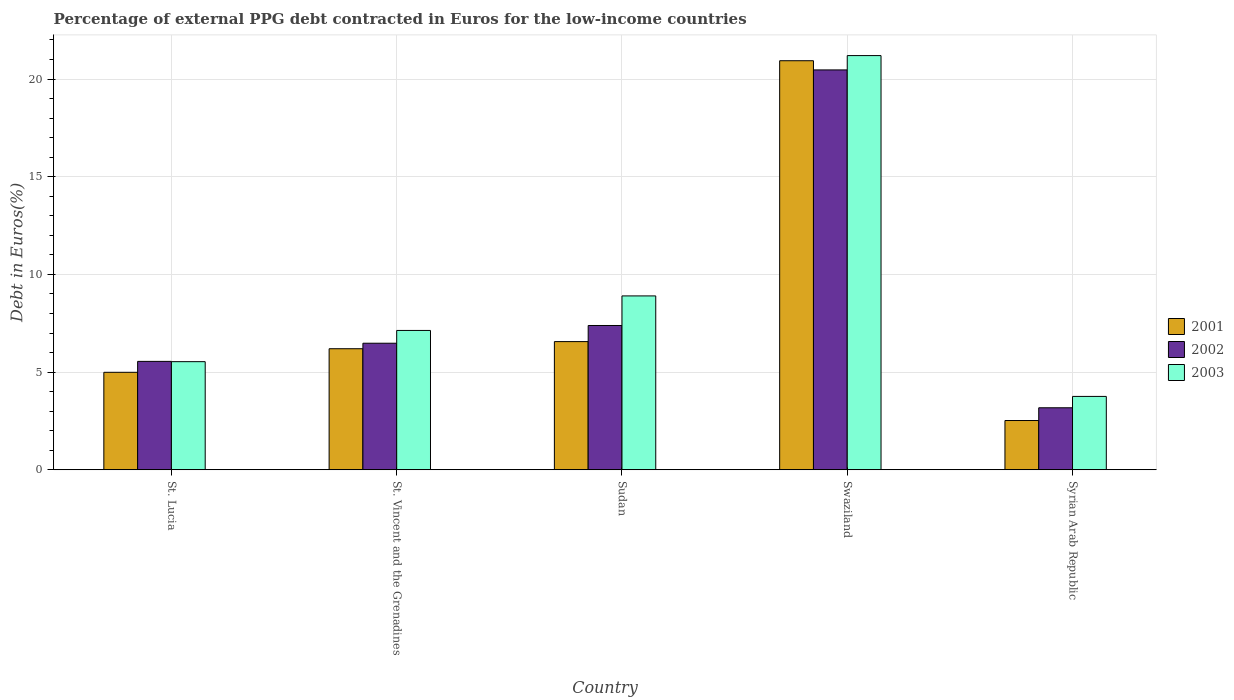How many bars are there on the 3rd tick from the left?
Ensure brevity in your answer.  3. What is the label of the 4th group of bars from the left?
Your answer should be very brief. Swaziland. In how many cases, is the number of bars for a given country not equal to the number of legend labels?
Offer a very short reply. 0. What is the percentage of external PPG debt contracted in Euros in 2002 in St. Vincent and the Grenadines?
Ensure brevity in your answer.  6.48. Across all countries, what is the maximum percentage of external PPG debt contracted in Euros in 2001?
Offer a very short reply. 20.94. Across all countries, what is the minimum percentage of external PPG debt contracted in Euros in 2003?
Give a very brief answer. 3.76. In which country was the percentage of external PPG debt contracted in Euros in 2003 maximum?
Your response must be concise. Swaziland. In which country was the percentage of external PPG debt contracted in Euros in 2002 minimum?
Give a very brief answer. Syrian Arab Republic. What is the total percentage of external PPG debt contracted in Euros in 2002 in the graph?
Your answer should be compact. 43.05. What is the difference between the percentage of external PPG debt contracted in Euros in 2002 in St. Lucia and that in Syrian Arab Republic?
Keep it short and to the point. 2.37. What is the difference between the percentage of external PPG debt contracted in Euros in 2001 in St. Lucia and the percentage of external PPG debt contracted in Euros in 2002 in Swaziland?
Provide a succinct answer. -15.48. What is the average percentage of external PPG debt contracted in Euros in 2001 per country?
Offer a very short reply. 8.24. What is the difference between the percentage of external PPG debt contracted in Euros of/in 2002 and percentage of external PPG debt contracted in Euros of/in 2001 in Swaziland?
Give a very brief answer. -0.47. What is the ratio of the percentage of external PPG debt contracted in Euros in 2001 in St. Vincent and the Grenadines to that in Syrian Arab Republic?
Keep it short and to the point. 2.46. Is the percentage of external PPG debt contracted in Euros in 2002 in St. Vincent and the Grenadines less than that in Syrian Arab Republic?
Keep it short and to the point. No. What is the difference between the highest and the second highest percentage of external PPG debt contracted in Euros in 2001?
Provide a succinct answer. 14.37. What is the difference between the highest and the lowest percentage of external PPG debt contracted in Euros in 2002?
Your answer should be very brief. 17.29. In how many countries, is the percentage of external PPG debt contracted in Euros in 2003 greater than the average percentage of external PPG debt contracted in Euros in 2003 taken over all countries?
Offer a terse response. 1. Does the graph contain any zero values?
Ensure brevity in your answer.  No. How are the legend labels stacked?
Your response must be concise. Vertical. What is the title of the graph?
Ensure brevity in your answer.  Percentage of external PPG debt contracted in Euros for the low-income countries. What is the label or title of the Y-axis?
Provide a succinct answer. Debt in Euros(%). What is the Debt in Euros(%) of 2001 in St. Lucia?
Provide a succinct answer. 4.99. What is the Debt in Euros(%) of 2002 in St. Lucia?
Offer a very short reply. 5.55. What is the Debt in Euros(%) of 2003 in St. Lucia?
Keep it short and to the point. 5.53. What is the Debt in Euros(%) of 2001 in St. Vincent and the Grenadines?
Ensure brevity in your answer.  6.2. What is the Debt in Euros(%) in 2002 in St. Vincent and the Grenadines?
Your answer should be compact. 6.48. What is the Debt in Euros(%) of 2003 in St. Vincent and the Grenadines?
Keep it short and to the point. 7.13. What is the Debt in Euros(%) of 2001 in Sudan?
Keep it short and to the point. 6.56. What is the Debt in Euros(%) in 2002 in Sudan?
Offer a terse response. 7.39. What is the Debt in Euros(%) of 2003 in Sudan?
Give a very brief answer. 8.9. What is the Debt in Euros(%) of 2001 in Swaziland?
Offer a terse response. 20.94. What is the Debt in Euros(%) in 2002 in Swaziland?
Ensure brevity in your answer.  20.47. What is the Debt in Euros(%) of 2003 in Swaziland?
Provide a succinct answer. 21.2. What is the Debt in Euros(%) of 2001 in Syrian Arab Republic?
Offer a terse response. 2.52. What is the Debt in Euros(%) in 2002 in Syrian Arab Republic?
Make the answer very short. 3.17. What is the Debt in Euros(%) of 2003 in Syrian Arab Republic?
Offer a terse response. 3.76. Across all countries, what is the maximum Debt in Euros(%) of 2001?
Provide a short and direct response. 20.94. Across all countries, what is the maximum Debt in Euros(%) in 2002?
Your answer should be very brief. 20.47. Across all countries, what is the maximum Debt in Euros(%) of 2003?
Provide a short and direct response. 21.2. Across all countries, what is the minimum Debt in Euros(%) of 2001?
Provide a succinct answer. 2.52. Across all countries, what is the minimum Debt in Euros(%) of 2002?
Keep it short and to the point. 3.17. Across all countries, what is the minimum Debt in Euros(%) of 2003?
Give a very brief answer. 3.76. What is the total Debt in Euros(%) in 2001 in the graph?
Offer a very short reply. 41.2. What is the total Debt in Euros(%) in 2002 in the graph?
Offer a terse response. 43.05. What is the total Debt in Euros(%) of 2003 in the graph?
Your answer should be very brief. 46.52. What is the difference between the Debt in Euros(%) of 2001 in St. Lucia and that in St. Vincent and the Grenadines?
Provide a succinct answer. -1.21. What is the difference between the Debt in Euros(%) of 2002 in St. Lucia and that in St. Vincent and the Grenadines?
Give a very brief answer. -0.93. What is the difference between the Debt in Euros(%) in 2003 in St. Lucia and that in St. Vincent and the Grenadines?
Provide a succinct answer. -1.6. What is the difference between the Debt in Euros(%) of 2001 in St. Lucia and that in Sudan?
Offer a very short reply. -1.57. What is the difference between the Debt in Euros(%) in 2002 in St. Lucia and that in Sudan?
Offer a very short reply. -1.84. What is the difference between the Debt in Euros(%) in 2003 in St. Lucia and that in Sudan?
Give a very brief answer. -3.37. What is the difference between the Debt in Euros(%) of 2001 in St. Lucia and that in Swaziland?
Make the answer very short. -15.95. What is the difference between the Debt in Euros(%) in 2002 in St. Lucia and that in Swaziland?
Your answer should be very brief. -14.92. What is the difference between the Debt in Euros(%) in 2003 in St. Lucia and that in Swaziland?
Provide a short and direct response. -15.66. What is the difference between the Debt in Euros(%) in 2001 in St. Lucia and that in Syrian Arab Republic?
Make the answer very short. 2.47. What is the difference between the Debt in Euros(%) in 2002 in St. Lucia and that in Syrian Arab Republic?
Your answer should be very brief. 2.37. What is the difference between the Debt in Euros(%) in 2003 in St. Lucia and that in Syrian Arab Republic?
Your response must be concise. 1.78. What is the difference between the Debt in Euros(%) of 2001 in St. Vincent and the Grenadines and that in Sudan?
Keep it short and to the point. -0.36. What is the difference between the Debt in Euros(%) in 2002 in St. Vincent and the Grenadines and that in Sudan?
Give a very brief answer. -0.91. What is the difference between the Debt in Euros(%) of 2003 in St. Vincent and the Grenadines and that in Sudan?
Your answer should be compact. -1.77. What is the difference between the Debt in Euros(%) of 2001 in St. Vincent and the Grenadines and that in Swaziland?
Your answer should be compact. -14.74. What is the difference between the Debt in Euros(%) of 2002 in St. Vincent and the Grenadines and that in Swaziland?
Your answer should be compact. -13.99. What is the difference between the Debt in Euros(%) in 2003 in St. Vincent and the Grenadines and that in Swaziland?
Your answer should be compact. -14.07. What is the difference between the Debt in Euros(%) in 2001 in St. Vincent and the Grenadines and that in Syrian Arab Republic?
Your answer should be very brief. 3.67. What is the difference between the Debt in Euros(%) of 2002 in St. Vincent and the Grenadines and that in Syrian Arab Republic?
Make the answer very short. 3.3. What is the difference between the Debt in Euros(%) of 2003 in St. Vincent and the Grenadines and that in Syrian Arab Republic?
Make the answer very short. 3.38. What is the difference between the Debt in Euros(%) of 2001 in Sudan and that in Swaziland?
Ensure brevity in your answer.  -14.37. What is the difference between the Debt in Euros(%) of 2002 in Sudan and that in Swaziland?
Your response must be concise. -13.08. What is the difference between the Debt in Euros(%) in 2003 in Sudan and that in Swaziland?
Your response must be concise. -12.3. What is the difference between the Debt in Euros(%) of 2001 in Sudan and that in Syrian Arab Republic?
Provide a short and direct response. 4.04. What is the difference between the Debt in Euros(%) in 2002 in Sudan and that in Syrian Arab Republic?
Your answer should be very brief. 4.21. What is the difference between the Debt in Euros(%) of 2003 in Sudan and that in Syrian Arab Republic?
Ensure brevity in your answer.  5.14. What is the difference between the Debt in Euros(%) of 2001 in Swaziland and that in Syrian Arab Republic?
Offer a terse response. 18.41. What is the difference between the Debt in Euros(%) in 2002 in Swaziland and that in Syrian Arab Republic?
Ensure brevity in your answer.  17.29. What is the difference between the Debt in Euros(%) of 2003 in Swaziland and that in Syrian Arab Republic?
Offer a very short reply. 17.44. What is the difference between the Debt in Euros(%) in 2001 in St. Lucia and the Debt in Euros(%) in 2002 in St. Vincent and the Grenadines?
Offer a terse response. -1.49. What is the difference between the Debt in Euros(%) of 2001 in St. Lucia and the Debt in Euros(%) of 2003 in St. Vincent and the Grenadines?
Make the answer very short. -2.14. What is the difference between the Debt in Euros(%) in 2002 in St. Lucia and the Debt in Euros(%) in 2003 in St. Vincent and the Grenadines?
Provide a short and direct response. -1.58. What is the difference between the Debt in Euros(%) in 2001 in St. Lucia and the Debt in Euros(%) in 2002 in Sudan?
Keep it short and to the point. -2.4. What is the difference between the Debt in Euros(%) of 2001 in St. Lucia and the Debt in Euros(%) of 2003 in Sudan?
Your answer should be very brief. -3.91. What is the difference between the Debt in Euros(%) in 2002 in St. Lucia and the Debt in Euros(%) in 2003 in Sudan?
Your response must be concise. -3.35. What is the difference between the Debt in Euros(%) in 2001 in St. Lucia and the Debt in Euros(%) in 2002 in Swaziland?
Offer a very short reply. -15.48. What is the difference between the Debt in Euros(%) in 2001 in St. Lucia and the Debt in Euros(%) in 2003 in Swaziland?
Keep it short and to the point. -16.21. What is the difference between the Debt in Euros(%) in 2002 in St. Lucia and the Debt in Euros(%) in 2003 in Swaziland?
Your response must be concise. -15.65. What is the difference between the Debt in Euros(%) of 2001 in St. Lucia and the Debt in Euros(%) of 2002 in Syrian Arab Republic?
Keep it short and to the point. 1.81. What is the difference between the Debt in Euros(%) of 2001 in St. Lucia and the Debt in Euros(%) of 2003 in Syrian Arab Republic?
Your answer should be very brief. 1.23. What is the difference between the Debt in Euros(%) in 2002 in St. Lucia and the Debt in Euros(%) in 2003 in Syrian Arab Republic?
Your answer should be very brief. 1.79. What is the difference between the Debt in Euros(%) in 2001 in St. Vincent and the Grenadines and the Debt in Euros(%) in 2002 in Sudan?
Keep it short and to the point. -1.19. What is the difference between the Debt in Euros(%) of 2001 in St. Vincent and the Grenadines and the Debt in Euros(%) of 2003 in Sudan?
Offer a very short reply. -2.7. What is the difference between the Debt in Euros(%) of 2002 in St. Vincent and the Grenadines and the Debt in Euros(%) of 2003 in Sudan?
Ensure brevity in your answer.  -2.42. What is the difference between the Debt in Euros(%) of 2001 in St. Vincent and the Grenadines and the Debt in Euros(%) of 2002 in Swaziland?
Keep it short and to the point. -14.27. What is the difference between the Debt in Euros(%) in 2001 in St. Vincent and the Grenadines and the Debt in Euros(%) in 2003 in Swaziland?
Make the answer very short. -15. What is the difference between the Debt in Euros(%) in 2002 in St. Vincent and the Grenadines and the Debt in Euros(%) in 2003 in Swaziland?
Give a very brief answer. -14.72. What is the difference between the Debt in Euros(%) in 2001 in St. Vincent and the Grenadines and the Debt in Euros(%) in 2002 in Syrian Arab Republic?
Your answer should be compact. 3.02. What is the difference between the Debt in Euros(%) of 2001 in St. Vincent and the Grenadines and the Debt in Euros(%) of 2003 in Syrian Arab Republic?
Your response must be concise. 2.44. What is the difference between the Debt in Euros(%) in 2002 in St. Vincent and the Grenadines and the Debt in Euros(%) in 2003 in Syrian Arab Republic?
Make the answer very short. 2.72. What is the difference between the Debt in Euros(%) in 2001 in Sudan and the Debt in Euros(%) in 2002 in Swaziland?
Offer a very short reply. -13.9. What is the difference between the Debt in Euros(%) of 2001 in Sudan and the Debt in Euros(%) of 2003 in Swaziland?
Make the answer very short. -14.64. What is the difference between the Debt in Euros(%) in 2002 in Sudan and the Debt in Euros(%) in 2003 in Swaziland?
Your response must be concise. -13.81. What is the difference between the Debt in Euros(%) in 2001 in Sudan and the Debt in Euros(%) in 2002 in Syrian Arab Republic?
Your response must be concise. 3.39. What is the difference between the Debt in Euros(%) of 2001 in Sudan and the Debt in Euros(%) of 2003 in Syrian Arab Republic?
Provide a short and direct response. 2.8. What is the difference between the Debt in Euros(%) in 2002 in Sudan and the Debt in Euros(%) in 2003 in Syrian Arab Republic?
Provide a short and direct response. 3.63. What is the difference between the Debt in Euros(%) in 2001 in Swaziland and the Debt in Euros(%) in 2002 in Syrian Arab Republic?
Make the answer very short. 17.76. What is the difference between the Debt in Euros(%) in 2001 in Swaziland and the Debt in Euros(%) in 2003 in Syrian Arab Republic?
Keep it short and to the point. 17.18. What is the difference between the Debt in Euros(%) in 2002 in Swaziland and the Debt in Euros(%) in 2003 in Syrian Arab Republic?
Your response must be concise. 16.71. What is the average Debt in Euros(%) in 2001 per country?
Provide a succinct answer. 8.24. What is the average Debt in Euros(%) of 2002 per country?
Your response must be concise. 8.61. What is the average Debt in Euros(%) of 2003 per country?
Offer a terse response. 9.3. What is the difference between the Debt in Euros(%) of 2001 and Debt in Euros(%) of 2002 in St. Lucia?
Ensure brevity in your answer.  -0.56. What is the difference between the Debt in Euros(%) of 2001 and Debt in Euros(%) of 2003 in St. Lucia?
Give a very brief answer. -0.54. What is the difference between the Debt in Euros(%) of 2002 and Debt in Euros(%) of 2003 in St. Lucia?
Your response must be concise. 0.01. What is the difference between the Debt in Euros(%) in 2001 and Debt in Euros(%) in 2002 in St. Vincent and the Grenadines?
Your answer should be very brief. -0.28. What is the difference between the Debt in Euros(%) in 2001 and Debt in Euros(%) in 2003 in St. Vincent and the Grenadines?
Keep it short and to the point. -0.94. What is the difference between the Debt in Euros(%) of 2002 and Debt in Euros(%) of 2003 in St. Vincent and the Grenadines?
Your response must be concise. -0.65. What is the difference between the Debt in Euros(%) in 2001 and Debt in Euros(%) in 2002 in Sudan?
Your response must be concise. -0.82. What is the difference between the Debt in Euros(%) in 2001 and Debt in Euros(%) in 2003 in Sudan?
Provide a short and direct response. -2.34. What is the difference between the Debt in Euros(%) in 2002 and Debt in Euros(%) in 2003 in Sudan?
Provide a succinct answer. -1.51. What is the difference between the Debt in Euros(%) in 2001 and Debt in Euros(%) in 2002 in Swaziland?
Make the answer very short. 0.47. What is the difference between the Debt in Euros(%) in 2001 and Debt in Euros(%) in 2003 in Swaziland?
Ensure brevity in your answer.  -0.26. What is the difference between the Debt in Euros(%) in 2002 and Debt in Euros(%) in 2003 in Swaziland?
Your response must be concise. -0.73. What is the difference between the Debt in Euros(%) in 2001 and Debt in Euros(%) in 2002 in Syrian Arab Republic?
Give a very brief answer. -0.65. What is the difference between the Debt in Euros(%) in 2001 and Debt in Euros(%) in 2003 in Syrian Arab Republic?
Offer a very short reply. -1.23. What is the difference between the Debt in Euros(%) of 2002 and Debt in Euros(%) of 2003 in Syrian Arab Republic?
Provide a succinct answer. -0.58. What is the ratio of the Debt in Euros(%) of 2001 in St. Lucia to that in St. Vincent and the Grenadines?
Your answer should be very brief. 0.81. What is the ratio of the Debt in Euros(%) in 2002 in St. Lucia to that in St. Vincent and the Grenadines?
Your response must be concise. 0.86. What is the ratio of the Debt in Euros(%) of 2003 in St. Lucia to that in St. Vincent and the Grenadines?
Keep it short and to the point. 0.78. What is the ratio of the Debt in Euros(%) of 2001 in St. Lucia to that in Sudan?
Your response must be concise. 0.76. What is the ratio of the Debt in Euros(%) of 2002 in St. Lucia to that in Sudan?
Your answer should be very brief. 0.75. What is the ratio of the Debt in Euros(%) in 2003 in St. Lucia to that in Sudan?
Offer a very short reply. 0.62. What is the ratio of the Debt in Euros(%) of 2001 in St. Lucia to that in Swaziland?
Provide a succinct answer. 0.24. What is the ratio of the Debt in Euros(%) in 2002 in St. Lucia to that in Swaziland?
Keep it short and to the point. 0.27. What is the ratio of the Debt in Euros(%) of 2003 in St. Lucia to that in Swaziland?
Ensure brevity in your answer.  0.26. What is the ratio of the Debt in Euros(%) of 2001 in St. Lucia to that in Syrian Arab Republic?
Provide a short and direct response. 1.98. What is the ratio of the Debt in Euros(%) of 2002 in St. Lucia to that in Syrian Arab Republic?
Your answer should be compact. 1.75. What is the ratio of the Debt in Euros(%) in 2003 in St. Lucia to that in Syrian Arab Republic?
Keep it short and to the point. 1.47. What is the ratio of the Debt in Euros(%) of 2002 in St. Vincent and the Grenadines to that in Sudan?
Make the answer very short. 0.88. What is the ratio of the Debt in Euros(%) in 2003 in St. Vincent and the Grenadines to that in Sudan?
Offer a very short reply. 0.8. What is the ratio of the Debt in Euros(%) of 2001 in St. Vincent and the Grenadines to that in Swaziland?
Provide a short and direct response. 0.3. What is the ratio of the Debt in Euros(%) in 2002 in St. Vincent and the Grenadines to that in Swaziland?
Offer a very short reply. 0.32. What is the ratio of the Debt in Euros(%) of 2003 in St. Vincent and the Grenadines to that in Swaziland?
Your answer should be compact. 0.34. What is the ratio of the Debt in Euros(%) of 2001 in St. Vincent and the Grenadines to that in Syrian Arab Republic?
Provide a succinct answer. 2.46. What is the ratio of the Debt in Euros(%) of 2002 in St. Vincent and the Grenadines to that in Syrian Arab Republic?
Your response must be concise. 2.04. What is the ratio of the Debt in Euros(%) in 2003 in St. Vincent and the Grenadines to that in Syrian Arab Republic?
Give a very brief answer. 1.9. What is the ratio of the Debt in Euros(%) in 2001 in Sudan to that in Swaziland?
Your answer should be very brief. 0.31. What is the ratio of the Debt in Euros(%) in 2002 in Sudan to that in Swaziland?
Offer a terse response. 0.36. What is the ratio of the Debt in Euros(%) of 2003 in Sudan to that in Swaziland?
Provide a short and direct response. 0.42. What is the ratio of the Debt in Euros(%) in 2001 in Sudan to that in Syrian Arab Republic?
Offer a very short reply. 2.6. What is the ratio of the Debt in Euros(%) of 2002 in Sudan to that in Syrian Arab Republic?
Make the answer very short. 2.33. What is the ratio of the Debt in Euros(%) in 2003 in Sudan to that in Syrian Arab Republic?
Your answer should be compact. 2.37. What is the ratio of the Debt in Euros(%) of 2001 in Swaziland to that in Syrian Arab Republic?
Provide a succinct answer. 8.3. What is the ratio of the Debt in Euros(%) in 2002 in Swaziland to that in Syrian Arab Republic?
Ensure brevity in your answer.  6.45. What is the ratio of the Debt in Euros(%) of 2003 in Swaziland to that in Syrian Arab Republic?
Make the answer very short. 5.64. What is the difference between the highest and the second highest Debt in Euros(%) in 2001?
Your answer should be very brief. 14.37. What is the difference between the highest and the second highest Debt in Euros(%) in 2002?
Ensure brevity in your answer.  13.08. What is the difference between the highest and the second highest Debt in Euros(%) of 2003?
Ensure brevity in your answer.  12.3. What is the difference between the highest and the lowest Debt in Euros(%) in 2001?
Your answer should be compact. 18.41. What is the difference between the highest and the lowest Debt in Euros(%) of 2002?
Offer a terse response. 17.29. What is the difference between the highest and the lowest Debt in Euros(%) in 2003?
Make the answer very short. 17.44. 